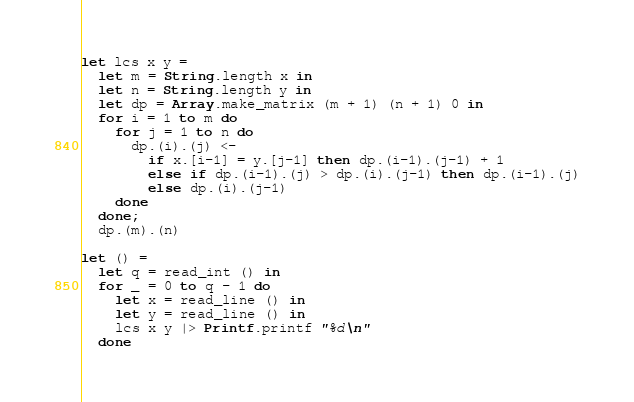<code> <loc_0><loc_0><loc_500><loc_500><_OCaml_>let lcs x y =
  let m = String.length x in
  let n = String.length y in
  let dp = Array.make_matrix (m + 1) (n + 1) 0 in
  for i = 1 to m do
    for j = 1 to n do
      dp.(i).(j) <-
        if x.[i-1] = y.[j-1] then dp.(i-1).(j-1) + 1
        else if dp.(i-1).(j) > dp.(i).(j-1) then dp.(i-1).(j)
        else dp.(i).(j-1)
    done
  done;
  dp.(m).(n)

let () =
  let q = read_int () in
  for _ = 0 to q - 1 do
    let x = read_line () in
    let y = read_line () in
    lcs x y |> Printf.printf "%d\n"
  done</code> 